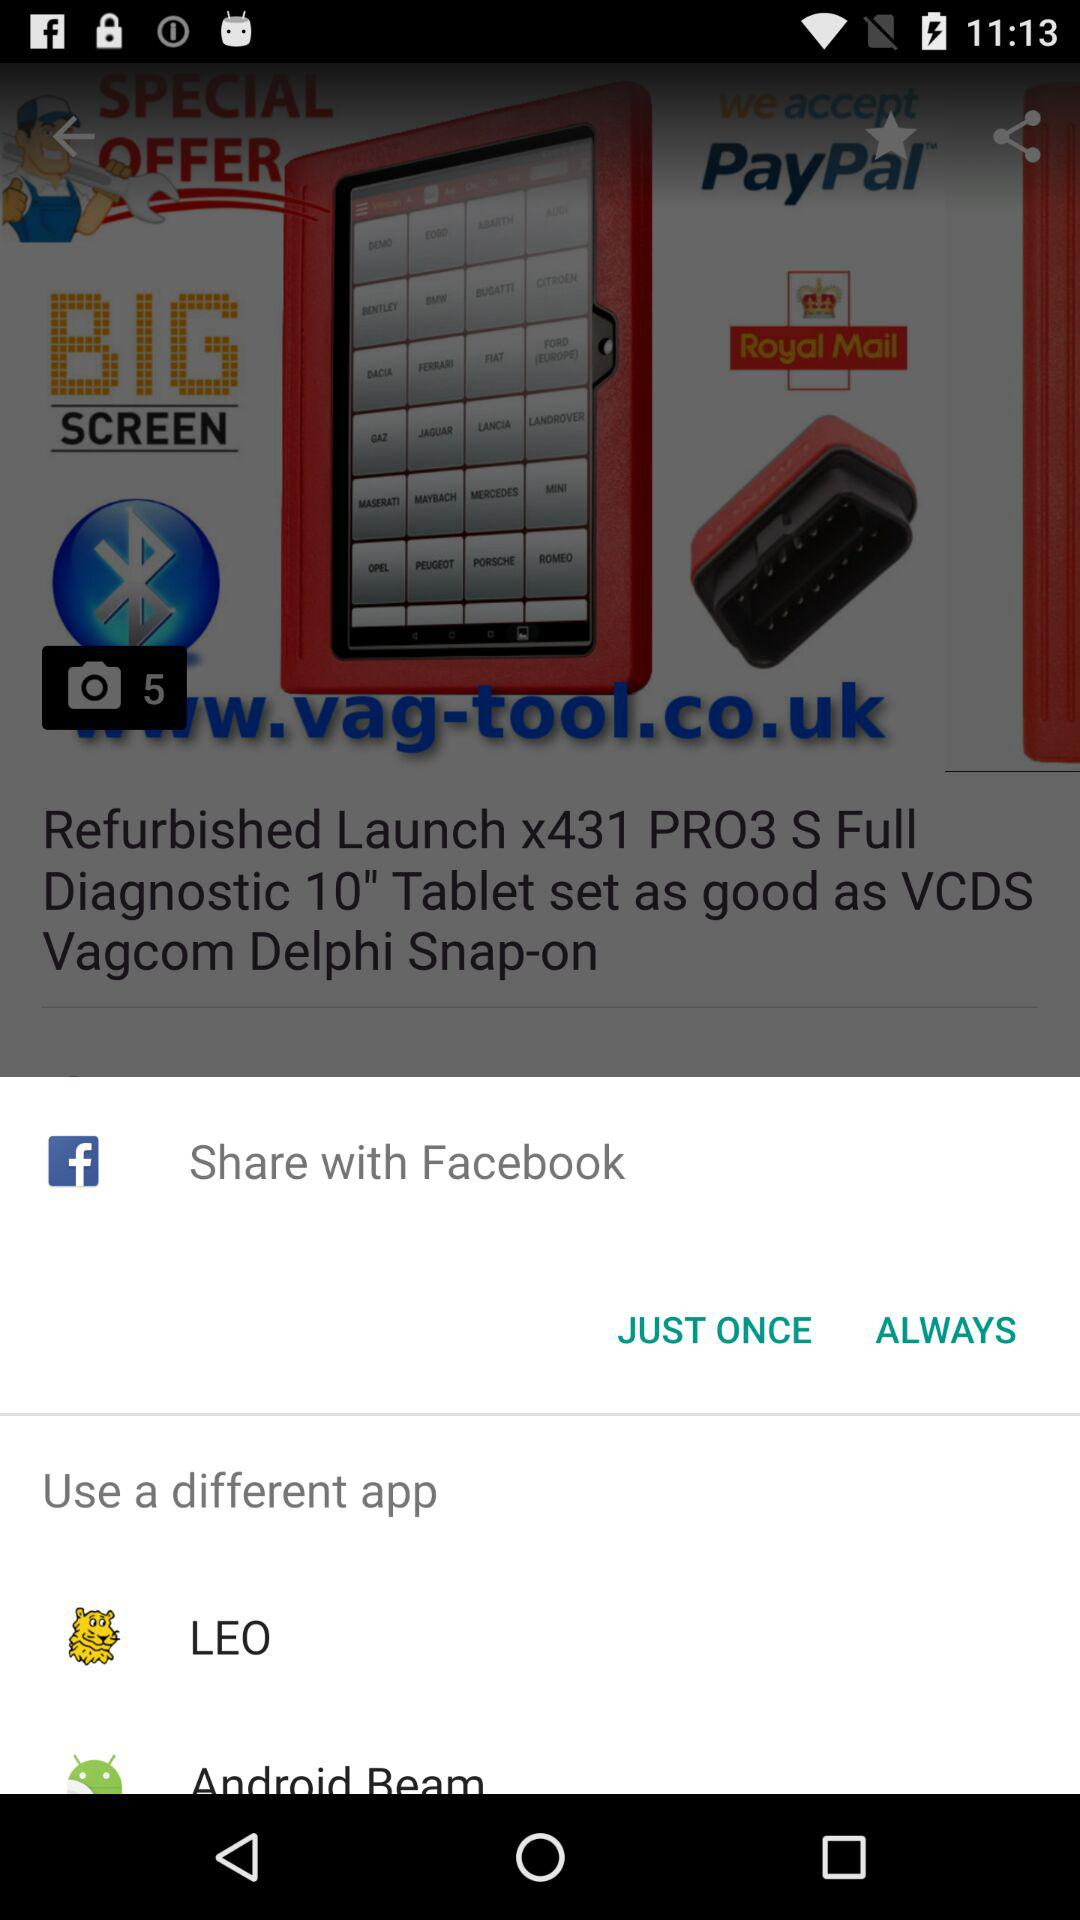What is the sharing option? The sharing options are "Facebook" and "LEO". 